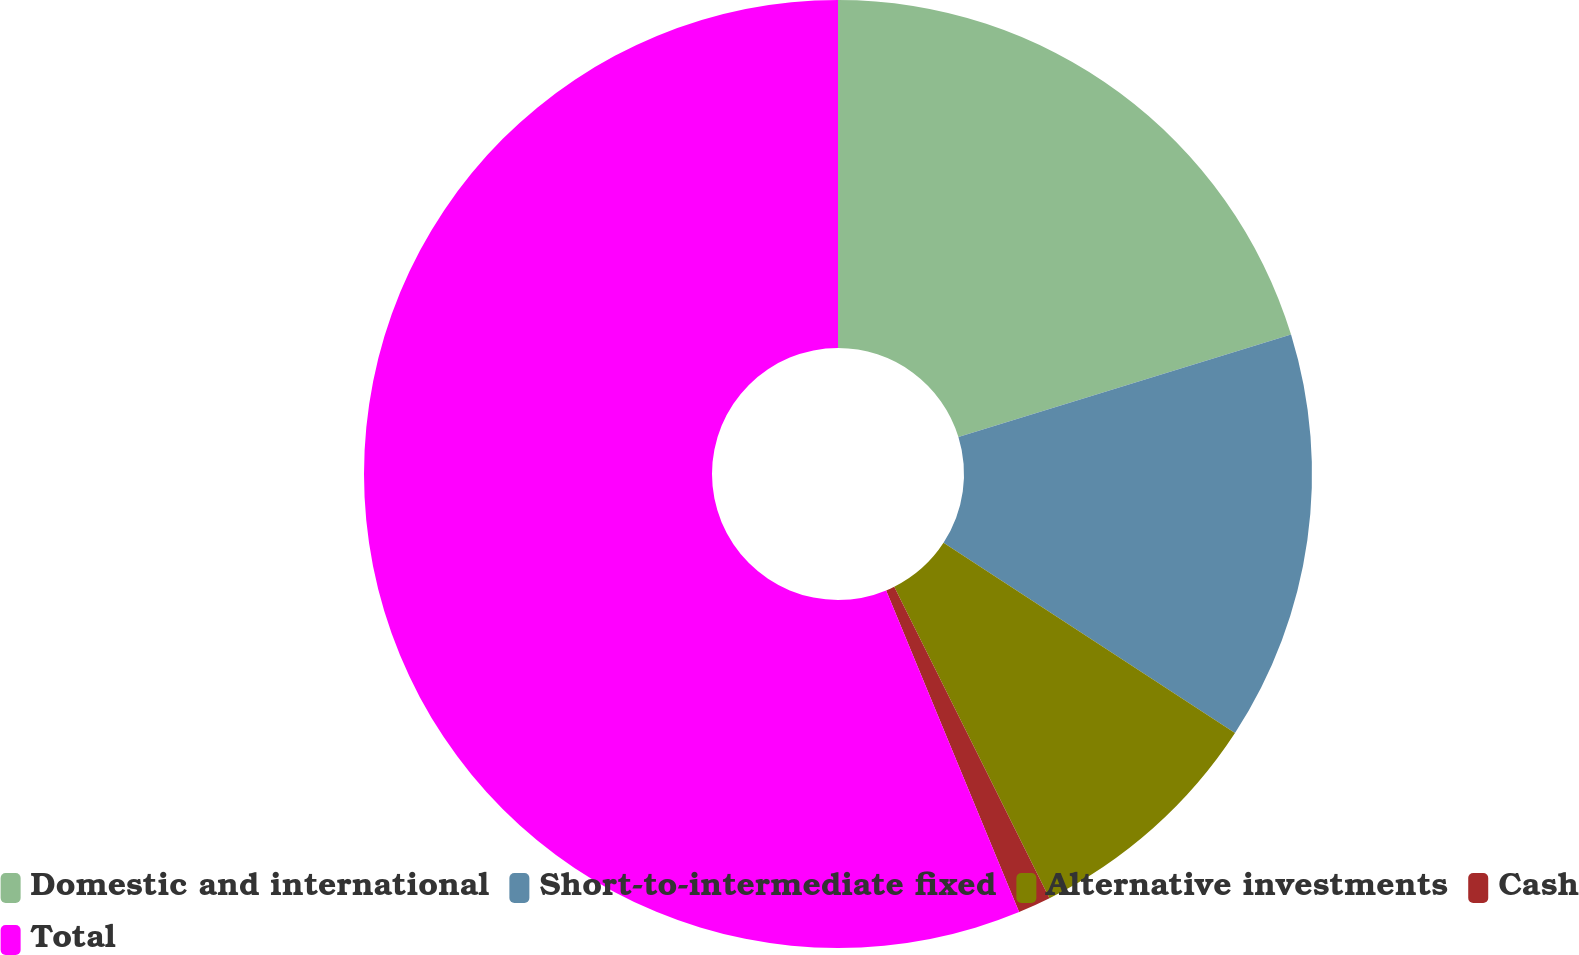Convert chart to OTSL. <chart><loc_0><loc_0><loc_500><loc_500><pie_chart><fcel>Domestic and international<fcel>Short-to-intermediate fixed<fcel>Alternative investments<fcel>Cash<fcel>Total<nl><fcel>20.25%<fcel>13.95%<fcel>8.44%<fcel>1.12%<fcel>56.24%<nl></chart> 